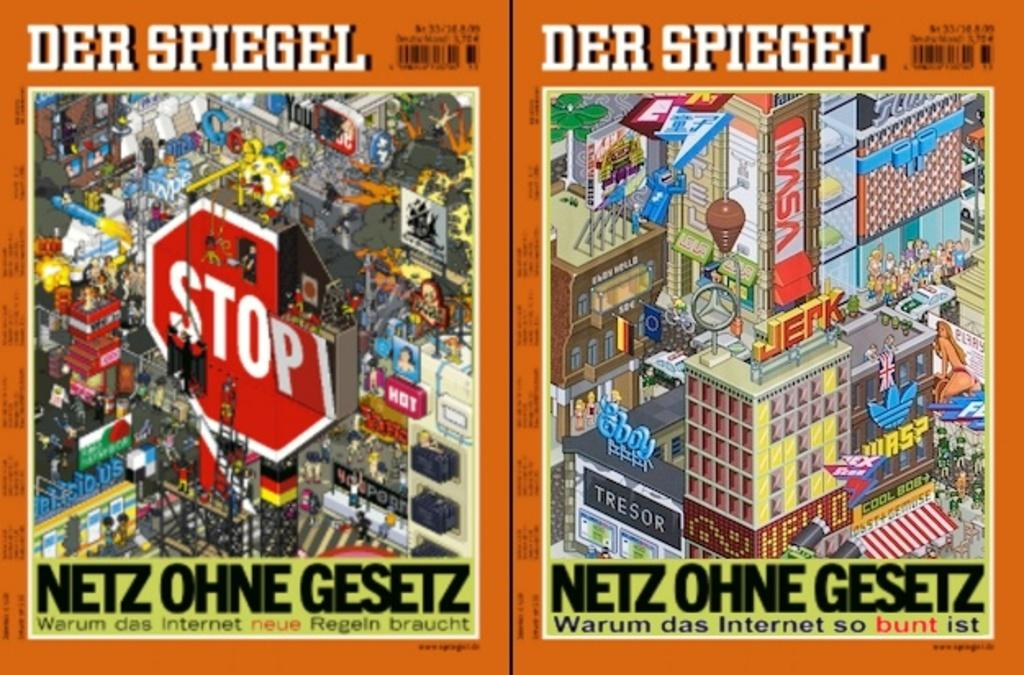<image>
Provide a brief description of the given image. Covers from Der Spiegel discussing the internet and Netz Ohne Gesetz. 